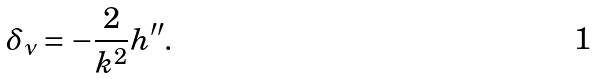<formula> <loc_0><loc_0><loc_500><loc_500>\delta _ { \nu } = - \frac { 2 } { k ^ { 2 } } h ^ { \prime \prime } .</formula> 